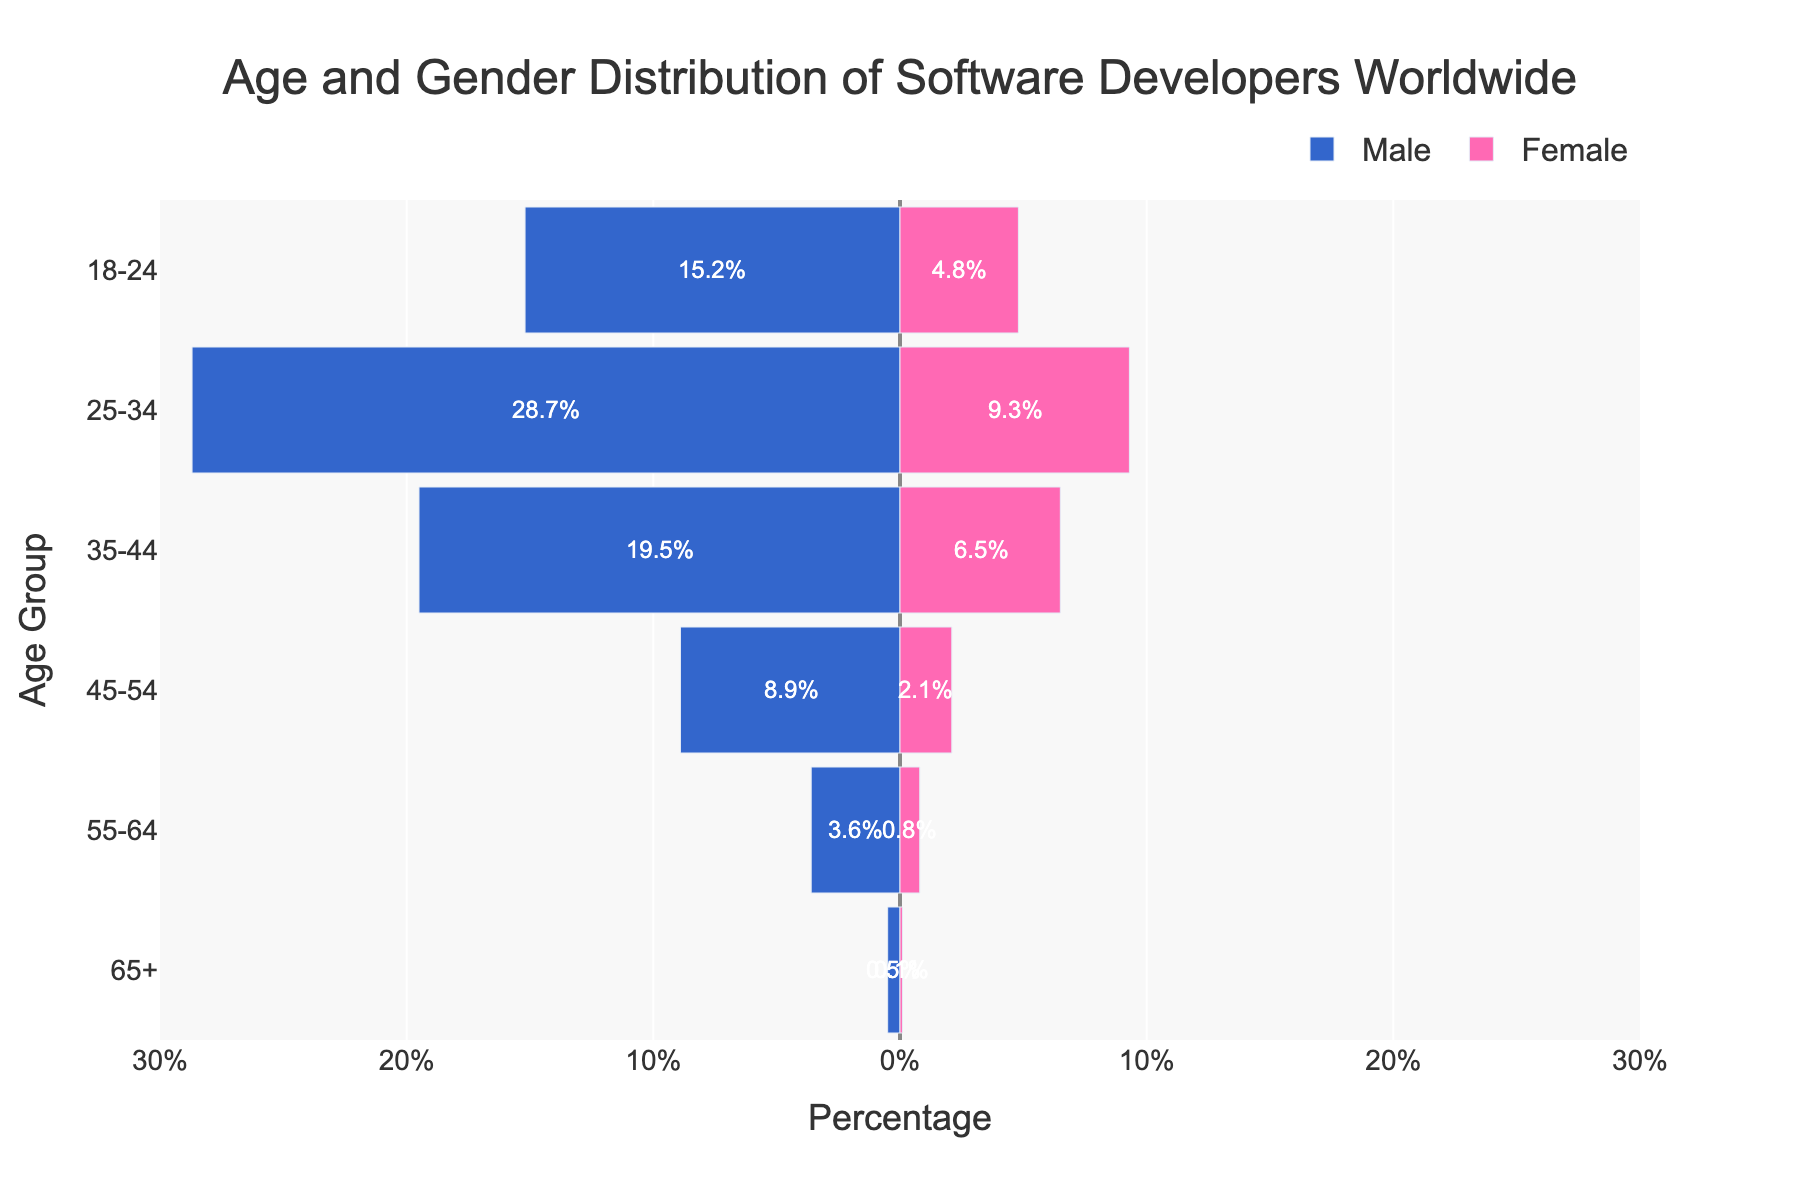What is the range of the percentage axis? The percentage axis, represented by the horizontal axis, ranges from -30% to 30%, indicating symmetric percentages for both genders. This is evident from the tick marks and labels on the x-axis.
Answer: -30% to 30% Which age group has the highest percentage of male software developers? The age group with the highest percentage of male software developers is 25-34 years. This can be observed from the length of the bars on the left side of the pyramid, with the 25-34 male bar being the longest.
Answer: 25-34 years What is the percentage difference between male and female developers in the 18-24 age group? The percentage of male developers in the 18-24 age group is 15.2%, and female developers are 4.8%. The difference is calculated as 15.2% - 4.8% = 10.4%.
Answer: 10.4% Which gender has a higher percentage of developers aged 35-44 years? By comparing the lengths of the bars for the 35-44 age group, we see that the male bar is longer than the female bar. Thus, the percentage of male developers is higher in this age group.
Answer: Male What is the combined percentage of male and female developers in the 65+ age group? The percentage of male developers in the 65+ age group is 0.5%, and female developers are 0.1%. Adding these gives us 0.5% + 0.1% = 0.6%.
Answer: 0.6% How does the gender distribution change as age increases? The male percentage decreases from 15.2% in the 18-24 group to 0.5% in the 65+ group, and the female percentage decreases from 4.8% in the 18-24 group to 0.1% in the 65+ group. This indicates a consistent decline in both male and female percentages with increasing age.
Answer: Both decrease What age group has the smallest gender gap between male and female software developers? The smallest gender gap can be observed in the 55-64 age group, where the percentage of male developers is 3.6% and female developers is 0.8%. The difference is 3.6% - 0.8% = 2.8%, which is the smallest difference compared to other age groups.
Answer: 55-64 years What is the primary color used to represent female developers in the pyramid? The primary color used to represent female developers in the pyramid is pink. This can be observed directly from the color of the bars on the right side of the population pyramid.
Answer: Pink What is the total percentage of all male developers across all age groups? Summing the percentages across all male age groups: 15.2% (18-24) + 28.7% (25-34) + 19.5% (35-44) + 8.9% (45-54) + 3.6% (55-64) + 0.5% (65+) = 76.4%.
Answer: 76.4% How many data points are there for each gender in the pyramid? There are six age groups in the pyramid, and each gender has one data point per age group. This totals to 6 data points for each gender.
Answer: 6 data points each 